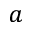Convert formula to latex. <formula><loc_0><loc_0><loc_500><loc_500>a</formula> 